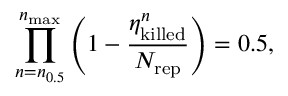Convert formula to latex. <formula><loc_0><loc_0><loc_500><loc_500>\prod _ { n = n _ { 0 . 5 } } ^ { n _ { \max } } \left ( 1 - \frac { \eta _ { k i l l e d } ^ { n } } { N _ { r e p } } \right ) = 0 . 5 ,</formula> 